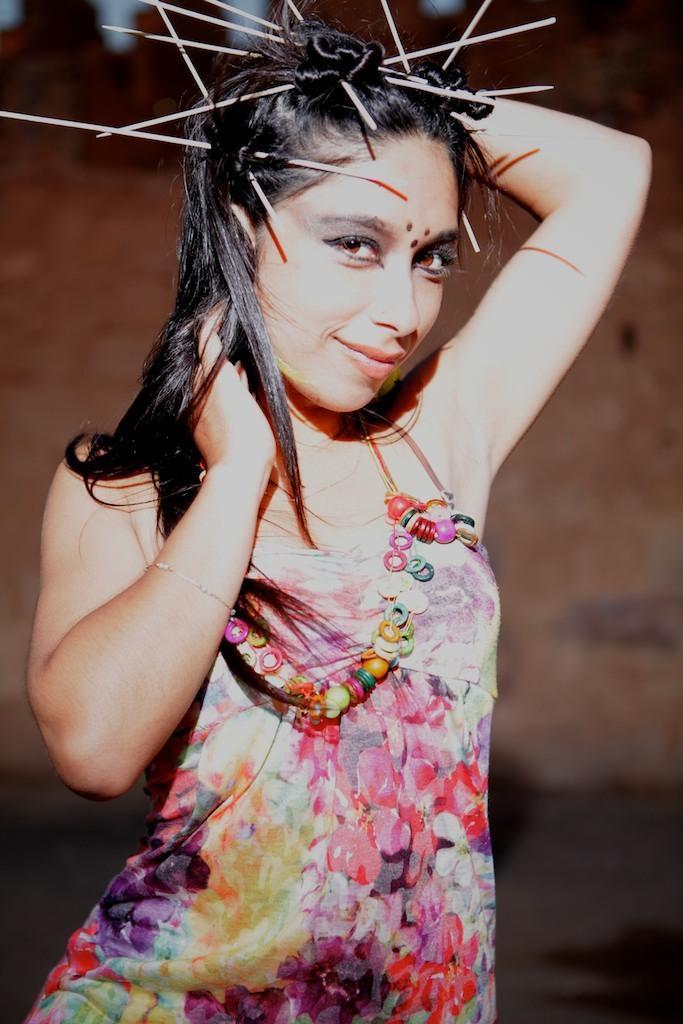Please provide a concise description of this image. In this image I can see a woman smiling. The background is blurred. 